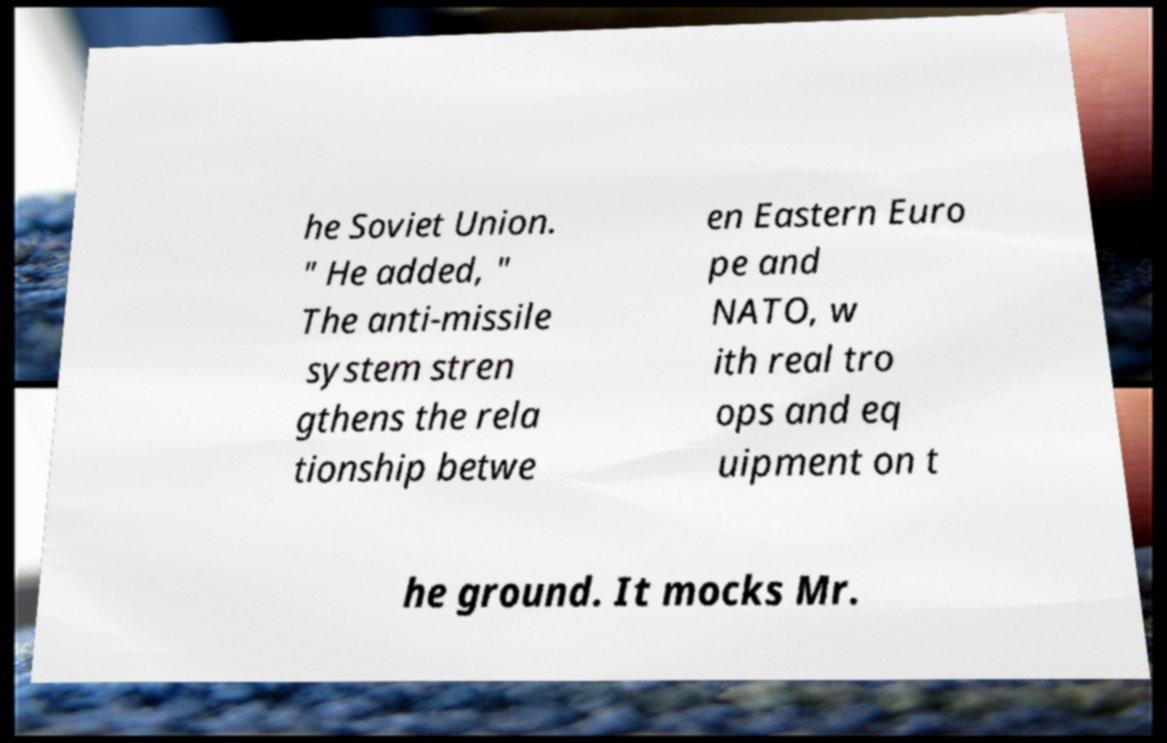Please read and relay the text visible in this image. What does it say? he Soviet Union. " He added, " The anti-missile system stren gthens the rela tionship betwe en Eastern Euro pe and NATO, w ith real tro ops and eq uipment on t he ground. It mocks Mr. 